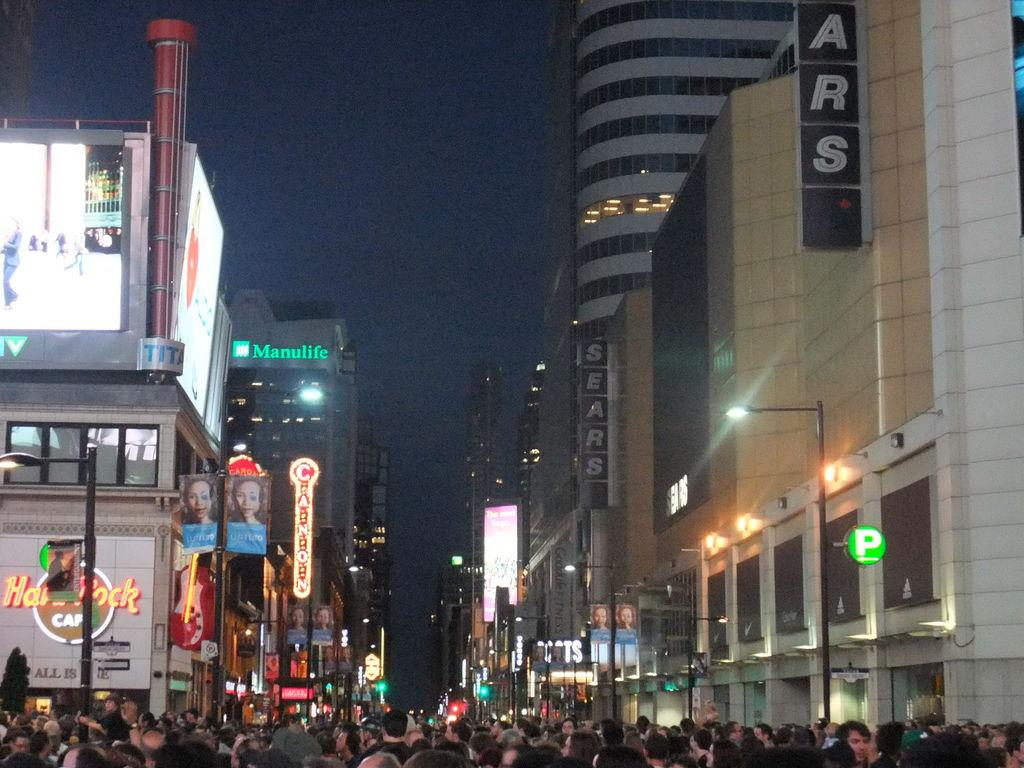<image>
Describe the image concisely. A busy area in the city shows many buildings including The Hard Rock Cafe. 